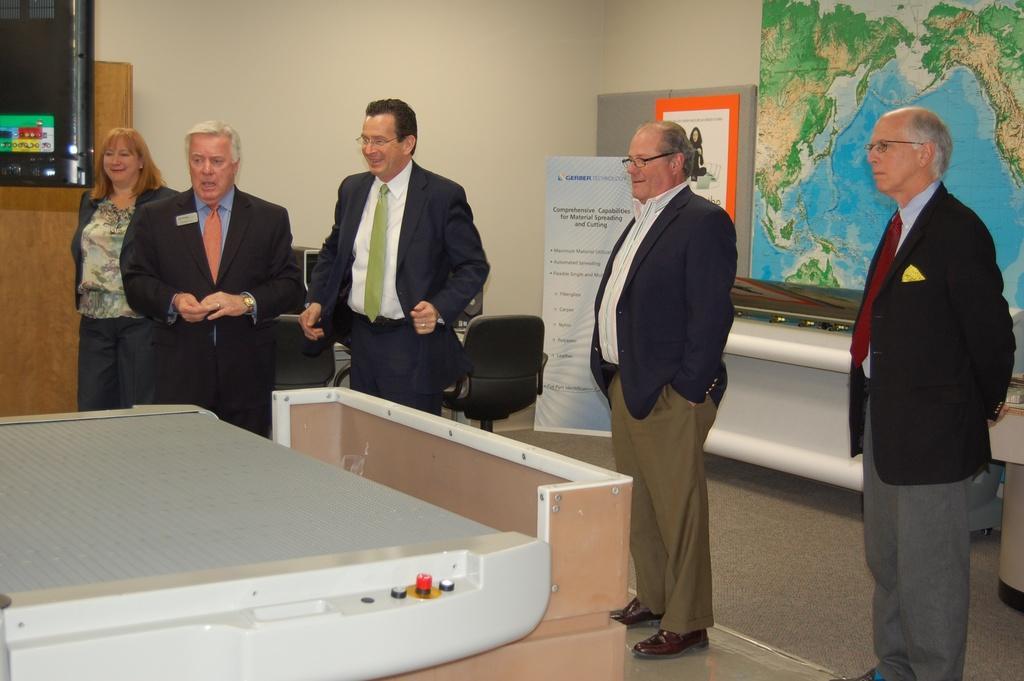Can you describe this image briefly? In the front of the image I can see five people are standing, in-front of them there is a machine. In the background of the image there is a map, banner, board, wall, chairs and things. At the top left side of the image there is an object. 